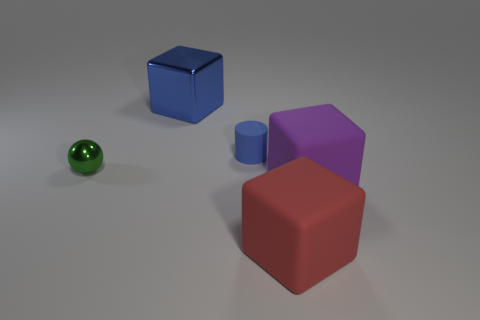Add 1 blue objects. How many objects exist? 6 Subtract all cylinders. How many objects are left? 4 Add 2 purple metal spheres. How many purple metal spheres exist? 2 Subtract 0 brown blocks. How many objects are left? 5 Subtract all matte cubes. Subtract all tiny things. How many objects are left? 1 Add 2 green metal spheres. How many green metal spheres are left? 3 